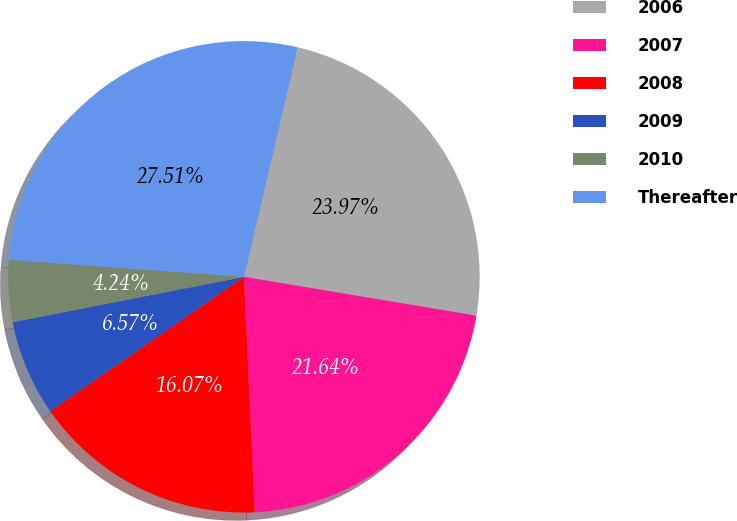Convert chart. <chart><loc_0><loc_0><loc_500><loc_500><pie_chart><fcel>2006<fcel>2007<fcel>2008<fcel>2009<fcel>2010<fcel>Thereafter<nl><fcel>23.97%<fcel>21.64%<fcel>16.07%<fcel>6.57%<fcel>4.24%<fcel>27.51%<nl></chart> 